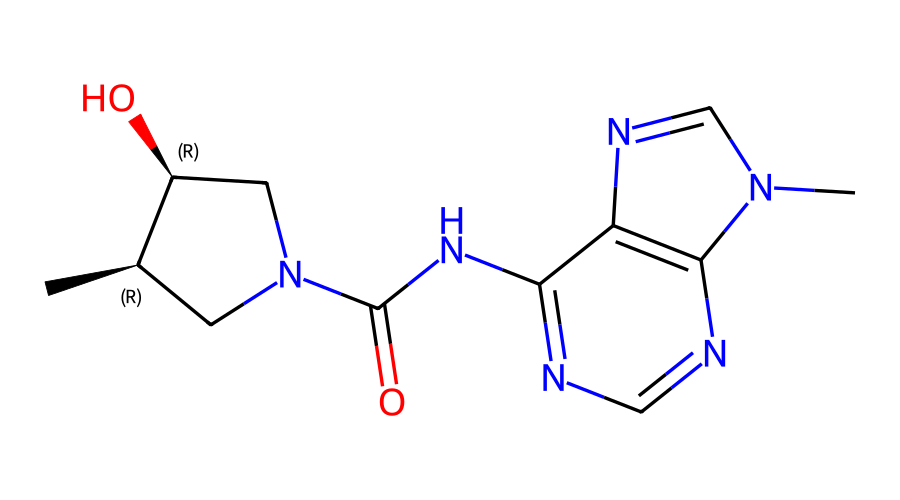What is the total number of nitrogen atoms in the structure? By analyzing the SMILES notation, we can count the nitrogen (N) atoms present in the structure. The notation "N" appears 5 times, indicating there are five nitrogen atoms in total.
Answer: five How many chiral centers are present in the compound? In the SMILES representation, chiral centers can be identified by the "@" symbols. There are 2 instances of "@" in the SMILES, signifying two chiral centers within the structure.
Answer: two What type of functional group is indicated by 'C(=O)N'? The segment 'C(=O)N' shows a carbon atom double-bonded to an oxygen atom and single-bonded to a nitrogen atom, which is characteristic of an amide functional group.
Answer: amide What is the ring size of the largest cyclic structure in the compound? By examining the cycles in the SMILES, we can find the largest ring formed. The notation indicates a total of 3 interconnected rings, and the largest one contains 6 atoms (5 carbons and 1 nitrogen).
Answer: six What class of drugs does this chemical likely belong to? Given the presence of multiple nitrogen atoms and the overall structure, this compound is likely an antiviral agent or similar to nucleoside analogs based on its chemical properties.
Answer: antiviral 